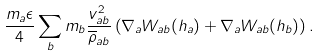Convert formula to latex. <formula><loc_0><loc_0><loc_500><loc_500>\frac { m _ { a } \epsilon } { 4 } \sum _ { b } m _ { b } \frac { v _ { a b } ^ { 2 } } { \overline { \rho } _ { a b } } \left ( \nabla _ { a } W _ { a b } ( h _ { a } ) + \nabla _ { a } W _ { a b } ( h _ { b } ) \right ) .</formula> 